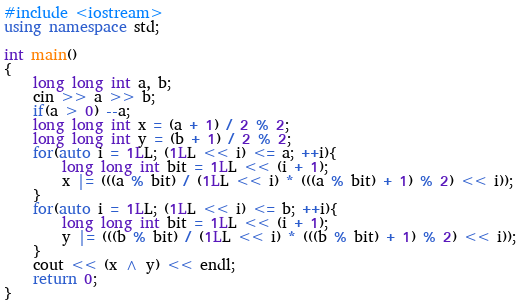<code> <loc_0><loc_0><loc_500><loc_500><_C++_>#include <iostream>
using namespace std;

int main()
{
	long long int a, b;
	cin >> a >> b;
	if(a > 0) --a;
	long long int x = (a + 1) / 2 % 2;
	long long int y = (b + 1) / 2 % 2;
	for(auto i = 1LL; (1LL << i) <= a; ++i){
		long long int bit = 1LL << (i + 1);
		x |= (((a % bit) / (1LL << i) * (((a % bit) + 1) % 2) << i));
	}
	for(auto i = 1LL; (1LL << i) <= b; ++i){
		long long int bit = 1LL << (i + 1);
		y |= (((b % bit) / (1LL << i) * (((b % bit) + 1) % 2) << i));
	}
	cout << (x ^ y) << endl;
	return 0;
}</code> 